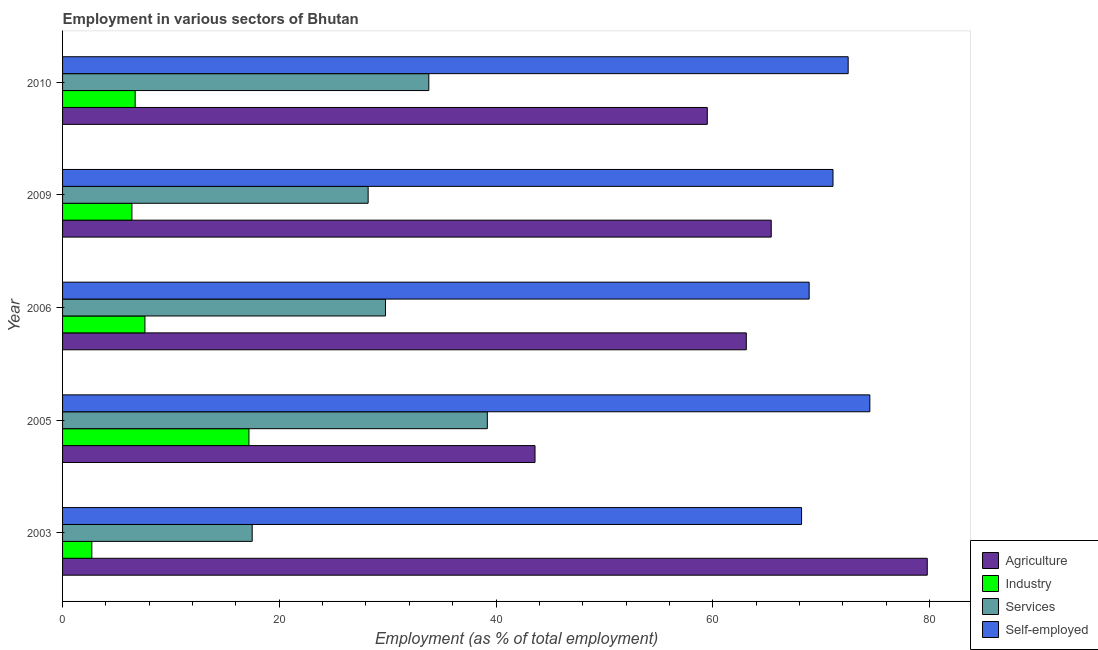Are the number of bars on each tick of the Y-axis equal?
Offer a terse response. Yes. What is the label of the 3rd group of bars from the top?
Offer a terse response. 2006. What is the percentage of workers in industry in 2005?
Your answer should be very brief. 17.2. Across all years, what is the maximum percentage of workers in services?
Your answer should be very brief. 39.2. Across all years, what is the minimum percentage of workers in agriculture?
Offer a terse response. 43.6. In which year was the percentage of self employed workers minimum?
Provide a succinct answer. 2003. What is the total percentage of workers in industry in the graph?
Keep it short and to the point. 40.6. What is the difference between the percentage of workers in industry in 2005 and that in 2010?
Keep it short and to the point. 10.5. What is the difference between the percentage of self employed workers in 2003 and the percentage of workers in industry in 2006?
Provide a short and direct response. 60.6. What is the average percentage of self employed workers per year?
Provide a short and direct response. 71.04. In the year 2010, what is the difference between the percentage of workers in industry and percentage of workers in agriculture?
Your answer should be very brief. -52.8. What is the ratio of the percentage of workers in agriculture in 2006 to that in 2010?
Your response must be concise. 1.06. Is the percentage of self employed workers in 2005 less than that in 2010?
Provide a short and direct response. No. Is the difference between the percentage of self employed workers in 2005 and 2006 greater than the difference between the percentage of workers in services in 2005 and 2006?
Offer a very short reply. No. What is the difference between the highest and the second highest percentage of workers in agriculture?
Your response must be concise. 14.4. What is the difference between the highest and the lowest percentage of workers in agriculture?
Your response must be concise. 36.2. In how many years, is the percentage of workers in industry greater than the average percentage of workers in industry taken over all years?
Give a very brief answer. 1. What does the 3rd bar from the top in 2009 represents?
Your answer should be compact. Industry. What does the 3rd bar from the bottom in 2003 represents?
Offer a terse response. Services. Is it the case that in every year, the sum of the percentage of workers in agriculture and percentage of workers in industry is greater than the percentage of workers in services?
Your answer should be very brief. Yes. Are all the bars in the graph horizontal?
Offer a terse response. Yes. How many years are there in the graph?
Your answer should be compact. 5. Are the values on the major ticks of X-axis written in scientific E-notation?
Provide a short and direct response. No. Does the graph contain any zero values?
Offer a very short reply. No. What is the title of the graph?
Provide a succinct answer. Employment in various sectors of Bhutan. Does "Subsidies and Transfers" appear as one of the legend labels in the graph?
Give a very brief answer. No. What is the label or title of the X-axis?
Your response must be concise. Employment (as % of total employment). What is the Employment (as % of total employment) of Agriculture in 2003?
Your answer should be very brief. 79.8. What is the Employment (as % of total employment) in Industry in 2003?
Offer a very short reply. 2.7. What is the Employment (as % of total employment) in Self-employed in 2003?
Offer a very short reply. 68.2. What is the Employment (as % of total employment) of Agriculture in 2005?
Make the answer very short. 43.6. What is the Employment (as % of total employment) of Industry in 2005?
Provide a succinct answer. 17.2. What is the Employment (as % of total employment) in Services in 2005?
Offer a terse response. 39.2. What is the Employment (as % of total employment) in Self-employed in 2005?
Your response must be concise. 74.5. What is the Employment (as % of total employment) of Agriculture in 2006?
Offer a very short reply. 63.1. What is the Employment (as % of total employment) of Industry in 2006?
Your answer should be compact. 7.6. What is the Employment (as % of total employment) of Services in 2006?
Keep it short and to the point. 29.8. What is the Employment (as % of total employment) of Self-employed in 2006?
Ensure brevity in your answer.  68.9. What is the Employment (as % of total employment) of Agriculture in 2009?
Provide a short and direct response. 65.4. What is the Employment (as % of total employment) of Industry in 2009?
Make the answer very short. 6.4. What is the Employment (as % of total employment) of Services in 2009?
Provide a short and direct response. 28.2. What is the Employment (as % of total employment) in Self-employed in 2009?
Your response must be concise. 71.1. What is the Employment (as % of total employment) in Agriculture in 2010?
Your answer should be compact. 59.5. What is the Employment (as % of total employment) in Industry in 2010?
Give a very brief answer. 6.7. What is the Employment (as % of total employment) of Services in 2010?
Your answer should be very brief. 33.8. What is the Employment (as % of total employment) of Self-employed in 2010?
Ensure brevity in your answer.  72.5. Across all years, what is the maximum Employment (as % of total employment) of Agriculture?
Keep it short and to the point. 79.8. Across all years, what is the maximum Employment (as % of total employment) in Industry?
Offer a terse response. 17.2. Across all years, what is the maximum Employment (as % of total employment) of Services?
Your answer should be compact. 39.2. Across all years, what is the maximum Employment (as % of total employment) in Self-employed?
Your response must be concise. 74.5. Across all years, what is the minimum Employment (as % of total employment) in Agriculture?
Give a very brief answer. 43.6. Across all years, what is the minimum Employment (as % of total employment) in Industry?
Your answer should be compact. 2.7. Across all years, what is the minimum Employment (as % of total employment) in Self-employed?
Offer a very short reply. 68.2. What is the total Employment (as % of total employment) in Agriculture in the graph?
Give a very brief answer. 311.4. What is the total Employment (as % of total employment) in Industry in the graph?
Provide a succinct answer. 40.6. What is the total Employment (as % of total employment) in Services in the graph?
Provide a short and direct response. 148.5. What is the total Employment (as % of total employment) of Self-employed in the graph?
Give a very brief answer. 355.2. What is the difference between the Employment (as % of total employment) of Agriculture in 2003 and that in 2005?
Give a very brief answer. 36.2. What is the difference between the Employment (as % of total employment) in Industry in 2003 and that in 2005?
Keep it short and to the point. -14.5. What is the difference between the Employment (as % of total employment) of Services in 2003 and that in 2005?
Your answer should be very brief. -21.7. What is the difference between the Employment (as % of total employment) in Industry in 2003 and that in 2006?
Keep it short and to the point. -4.9. What is the difference between the Employment (as % of total employment) in Self-employed in 2003 and that in 2006?
Ensure brevity in your answer.  -0.7. What is the difference between the Employment (as % of total employment) in Agriculture in 2003 and that in 2009?
Ensure brevity in your answer.  14.4. What is the difference between the Employment (as % of total employment) in Services in 2003 and that in 2009?
Provide a succinct answer. -10.7. What is the difference between the Employment (as % of total employment) of Agriculture in 2003 and that in 2010?
Your answer should be very brief. 20.3. What is the difference between the Employment (as % of total employment) in Industry in 2003 and that in 2010?
Give a very brief answer. -4. What is the difference between the Employment (as % of total employment) in Services in 2003 and that in 2010?
Your response must be concise. -16.3. What is the difference between the Employment (as % of total employment) of Agriculture in 2005 and that in 2006?
Give a very brief answer. -19.5. What is the difference between the Employment (as % of total employment) in Industry in 2005 and that in 2006?
Your answer should be compact. 9.6. What is the difference between the Employment (as % of total employment) in Agriculture in 2005 and that in 2009?
Your answer should be compact. -21.8. What is the difference between the Employment (as % of total employment) in Services in 2005 and that in 2009?
Ensure brevity in your answer.  11. What is the difference between the Employment (as % of total employment) of Self-employed in 2005 and that in 2009?
Ensure brevity in your answer.  3.4. What is the difference between the Employment (as % of total employment) in Agriculture in 2005 and that in 2010?
Offer a very short reply. -15.9. What is the difference between the Employment (as % of total employment) in Industry in 2005 and that in 2010?
Offer a terse response. 10.5. What is the difference between the Employment (as % of total employment) in Services in 2005 and that in 2010?
Keep it short and to the point. 5.4. What is the difference between the Employment (as % of total employment) in Self-employed in 2005 and that in 2010?
Your answer should be compact. 2. What is the difference between the Employment (as % of total employment) in Agriculture in 2006 and that in 2009?
Your answer should be very brief. -2.3. What is the difference between the Employment (as % of total employment) of Industry in 2006 and that in 2009?
Make the answer very short. 1.2. What is the difference between the Employment (as % of total employment) in Agriculture in 2006 and that in 2010?
Your answer should be compact. 3.6. What is the difference between the Employment (as % of total employment) in Self-employed in 2006 and that in 2010?
Keep it short and to the point. -3.6. What is the difference between the Employment (as % of total employment) in Agriculture in 2009 and that in 2010?
Your answer should be compact. 5.9. What is the difference between the Employment (as % of total employment) of Industry in 2009 and that in 2010?
Provide a succinct answer. -0.3. What is the difference between the Employment (as % of total employment) of Services in 2009 and that in 2010?
Your answer should be very brief. -5.6. What is the difference between the Employment (as % of total employment) of Agriculture in 2003 and the Employment (as % of total employment) of Industry in 2005?
Make the answer very short. 62.6. What is the difference between the Employment (as % of total employment) of Agriculture in 2003 and the Employment (as % of total employment) of Services in 2005?
Offer a very short reply. 40.6. What is the difference between the Employment (as % of total employment) in Industry in 2003 and the Employment (as % of total employment) in Services in 2005?
Make the answer very short. -36.5. What is the difference between the Employment (as % of total employment) in Industry in 2003 and the Employment (as % of total employment) in Self-employed in 2005?
Give a very brief answer. -71.8. What is the difference between the Employment (as % of total employment) of Services in 2003 and the Employment (as % of total employment) of Self-employed in 2005?
Provide a short and direct response. -57. What is the difference between the Employment (as % of total employment) in Agriculture in 2003 and the Employment (as % of total employment) in Industry in 2006?
Provide a short and direct response. 72.2. What is the difference between the Employment (as % of total employment) of Agriculture in 2003 and the Employment (as % of total employment) of Self-employed in 2006?
Your answer should be very brief. 10.9. What is the difference between the Employment (as % of total employment) in Industry in 2003 and the Employment (as % of total employment) in Services in 2006?
Make the answer very short. -27.1. What is the difference between the Employment (as % of total employment) of Industry in 2003 and the Employment (as % of total employment) of Self-employed in 2006?
Make the answer very short. -66.2. What is the difference between the Employment (as % of total employment) in Services in 2003 and the Employment (as % of total employment) in Self-employed in 2006?
Your answer should be very brief. -51.4. What is the difference between the Employment (as % of total employment) of Agriculture in 2003 and the Employment (as % of total employment) of Industry in 2009?
Make the answer very short. 73.4. What is the difference between the Employment (as % of total employment) of Agriculture in 2003 and the Employment (as % of total employment) of Services in 2009?
Make the answer very short. 51.6. What is the difference between the Employment (as % of total employment) in Agriculture in 2003 and the Employment (as % of total employment) in Self-employed in 2009?
Your answer should be compact. 8.7. What is the difference between the Employment (as % of total employment) of Industry in 2003 and the Employment (as % of total employment) of Services in 2009?
Provide a short and direct response. -25.5. What is the difference between the Employment (as % of total employment) in Industry in 2003 and the Employment (as % of total employment) in Self-employed in 2009?
Give a very brief answer. -68.4. What is the difference between the Employment (as % of total employment) in Services in 2003 and the Employment (as % of total employment) in Self-employed in 2009?
Your response must be concise. -53.6. What is the difference between the Employment (as % of total employment) of Agriculture in 2003 and the Employment (as % of total employment) of Industry in 2010?
Offer a very short reply. 73.1. What is the difference between the Employment (as % of total employment) of Industry in 2003 and the Employment (as % of total employment) of Services in 2010?
Ensure brevity in your answer.  -31.1. What is the difference between the Employment (as % of total employment) in Industry in 2003 and the Employment (as % of total employment) in Self-employed in 2010?
Your response must be concise. -69.8. What is the difference between the Employment (as % of total employment) of Services in 2003 and the Employment (as % of total employment) of Self-employed in 2010?
Make the answer very short. -55. What is the difference between the Employment (as % of total employment) in Agriculture in 2005 and the Employment (as % of total employment) in Industry in 2006?
Your answer should be compact. 36. What is the difference between the Employment (as % of total employment) of Agriculture in 2005 and the Employment (as % of total employment) of Services in 2006?
Offer a terse response. 13.8. What is the difference between the Employment (as % of total employment) in Agriculture in 2005 and the Employment (as % of total employment) in Self-employed in 2006?
Offer a very short reply. -25.3. What is the difference between the Employment (as % of total employment) of Industry in 2005 and the Employment (as % of total employment) of Self-employed in 2006?
Provide a short and direct response. -51.7. What is the difference between the Employment (as % of total employment) of Services in 2005 and the Employment (as % of total employment) of Self-employed in 2006?
Offer a terse response. -29.7. What is the difference between the Employment (as % of total employment) in Agriculture in 2005 and the Employment (as % of total employment) in Industry in 2009?
Provide a succinct answer. 37.2. What is the difference between the Employment (as % of total employment) of Agriculture in 2005 and the Employment (as % of total employment) of Self-employed in 2009?
Your answer should be compact. -27.5. What is the difference between the Employment (as % of total employment) of Industry in 2005 and the Employment (as % of total employment) of Services in 2009?
Offer a terse response. -11. What is the difference between the Employment (as % of total employment) in Industry in 2005 and the Employment (as % of total employment) in Self-employed in 2009?
Provide a short and direct response. -53.9. What is the difference between the Employment (as % of total employment) in Services in 2005 and the Employment (as % of total employment) in Self-employed in 2009?
Your answer should be very brief. -31.9. What is the difference between the Employment (as % of total employment) of Agriculture in 2005 and the Employment (as % of total employment) of Industry in 2010?
Provide a short and direct response. 36.9. What is the difference between the Employment (as % of total employment) of Agriculture in 2005 and the Employment (as % of total employment) of Self-employed in 2010?
Make the answer very short. -28.9. What is the difference between the Employment (as % of total employment) of Industry in 2005 and the Employment (as % of total employment) of Services in 2010?
Offer a terse response. -16.6. What is the difference between the Employment (as % of total employment) in Industry in 2005 and the Employment (as % of total employment) in Self-employed in 2010?
Your response must be concise. -55.3. What is the difference between the Employment (as % of total employment) in Services in 2005 and the Employment (as % of total employment) in Self-employed in 2010?
Offer a terse response. -33.3. What is the difference between the Employment (as % of total employment) of Agriculture in 2006 and the Employment (as % of total employment) of Industry in 2009?
Keep it short and to the point. 56.7. What is the difference between the Employment (as % of total employment) of Agriculture in 2006 and the Employment (as % of total employment) of Services in 2009?
Offer a very short reply. 34.9. What is the difference between the Employment (as % of total employment) of Industry in 2006 and the Employment (as % of total employment) of Services in 2009?
Make the answer very short. -20.6. What is the difference between the Employment (as % of total employment) of Industry in 2006 and the Employment (as % of total employment) of Self-employed in 2009?
Give a very brief answer. -63.5. What is the difference between the Employment (as % of total employment) in Services in 2006 and the Employment (as % of total employment) in Self-employed in 2009?
Your response must be concise. -41.3. What is the difference between the Employment (as % of total employment) in Agriculture in 2006 and the Employment (as % of total employment) in Industry in 2010?
Keep it short and to the point. 56.4. What is the difference between the Employment (as % of total employment) in Agriculture in 2006 and the Employment (as % of total employment) in Services in 2010?
Offer a terse response. 29.3. What is the difference between the Employment (as % of total employment) in Agriculture in 2006 and the Employment (as % of total employment) in Self-employed in 2010?
Ensure brevity in your answer.  -9.4. What is the difference between the Employment (as % of total employment) in Industry in 2006 and the Employment (as % of total employment) in Services in 2010?
Ensure brevity in your answer.  -26.2. What is the difference between the Employment (as % of total employment) in Industry in 2006 and the Employment (as % of total employment) in Self-employed in 2010?
Your answer should be compact. -64.9. What is the difference between the Employment (as % of total employment) of Services in 2006 and the Employment (as % of total employment) of Self-employed in 2010?
Offer a terse response. -42.7. What is the difference between the Employment (as % of total employment) in Agriculture in 2009 and the Employment (as % of total employment) in Industry in 2010?
Ensure brevity in your answer.  58.7. What is the difference between the Employment (as % of total employment) in Agriculture in 2009 and the Employment (as % of total employment) in Services in 2010?
Ensure brevity in your answer.  31.6. What is the difference between the Employment (as % of total employment) in Industry in 2009 and the Employment (as % of total employment) in Services in 2010?
Ensure brevity in your answer.  -27.4. What is the difference between the Employment (as % of total employment) of Industry in 2009 and the Employment (as % of total employment) of Self-employed in 2010?
Offer a very short reply. -66.1. What is the difference between the Employment (as % of total employment) of Services in 2009 and the Employment (as % of total employment) of Self-employed in 2010?
Offer a terse response. -44.3. What is the average Employment (as % of total employment) in Agriculture per year?
Provide a succinct answer. 62.28. What is the average Employment (as % of total employment) of Industry per year?
Your answer should be very brief. 8.12. What is the average Employment (as % of total employment) of Services per year?
Provide a succinct answer. 29.7. What is the average Employment (as % of total employment) of Self-employed per year?
Provide a succinct answer. 71.04. In the year 2003, what is the difference between the Employment (as % of total employment) of Agriculture and Employment (as % of total employment) of Industry?
Offer a terse response. 77.1. In the year 2003, what is the difference between the Employment (as % of total employment) of Agriculture and Employment (as % of total employment) of Services?
Your response must be concise. 62.3. In the year 2003, what is the difference between the Employment (as % of total employment) of Agriculture and Employment (as % of total employment) of Self-employed?
Ensure brevity in your answer.  11.6. In the year 2003, what is the difference between the Employment (as % of total employment) in Industry and Employment (as % of total employment) in Services?
Your answer should be very brief. -14.8. In the year 2003, what is the difference between the Employment (as % of total employment) of Industry and Employment (as % of total employment) of Self-employed?
Your answer should be compact. -65.5. In the year 2003, what is the difference between the Employment (as % of total employment) of Services and Employment (as % of total employment) of Self-employed?
Offer a terse response. -50.7. In the year 2005, what is the difference between the Employment (as % of total employment) of Agriculture and Employment (as % of total employment) of Industry?
Provide a short and direct response. 26.4. In the year 2005, what is the difference between the Employment (as % of total employment) in Agriculture and Employment (as % of total employment) in Services?
Offer a very short reply. 4.4. In the year 2005, what is the difference between the Employment (as % of total employment) in Agriculture and Employment (as % of total employment) in Self-employed?
Your response must be concise. -30.9. In the year 2005, what is the difference between the Employment (as % of total employment) in Industry and Employment (as % of total employment) in Self-employed?
Keep it short and to the point. -57.3. In the year 2005, what is the difference between the Employment (as % of total employment) in Services and Employment (as % of total employment) in Self-employed?
Make the answer very short. -35.3. In the year 2006, what is the difference between the Employment (as % of total employment) of Agriculture and Employment (as % of total employment) of Industry?
Provide a succinct answer. 55.5. In the year 2006, what is the difference between the Employment (as % of total employment) in Agriculture and Employment (as % of total employment) in Services?
Give a very brief answer. 33.3. In the year 2006, what is the difference between the Employment (as % of total employment) in Agriculture and Employment (as % of total employment) in Self-employed?
Ensure brevity in your answer.  -5.8. In the year 2006, what is the difference between the Employment (as % of total employment) of Industry and Employment (as % of total employment) of Services?
Keep it short and to the point. -22.2. In the year 2006, what is the difference between the Employment (as % of total employment) in Industry and Employment (as % of total employment) in Self-employed?
Keep it short and to the point. -61.3. In the year 2006, what is the difference between the Employment (as % of total employment) in Services and Employment (as % of total employment) in Self-employed?
Your answer should be compact. -39.1. In the year 2009, what is the difference between the Employment (as % of total employment) in Agriculture and Employment (as % of total employment) in Industry?
Provide a short and direct response. 59. In the year 2009, what is the difference between the Employment (as % of total employment) of Agriculture and Employment (as % of total employment) of Services?
Keep it short and to the point. 37.2. In the year 2009, what is the difference between the Employment (as % of total employment) of Agriculture and Employment (as % of total employment) of Self-employed?
Your response must be concise. -5.7. In the year 2009, what is the difference between the Employment (as % of total employment) of Industry and Employment (as % of total employment) of Services?
Make the answer very short. -21.8. In the year 2009, what is the difference between the Employment (as % of total employment) in Industry and Employment (as % of total employment) in Self-employed?
Your answer should be compact. -64.7. In the year 2009, what is the difference between the Employment (as % of total employment) in Services and Employment (as % of total employment) in Self-employed?
Keep it short and to the point. -42.9. In the year 2010, what is the difference between the Employment (as % of total employment) in Agriculture and Employment (as % of total employment) in Industry?
Your answer should be very brief. 52.8. In the year 2010, what is the difference between the Employment (as % of total employment) in Agriculture and Employment (as % of total employment) in Services?
Your response must be concise. 25.7. In the year 2010, what is the difference between the Employment (as % of total employment) in Industry and Employment (as % of total employment) in Services?
Keep it short and to the point. -27.1. In the year 2010, what is the difference between the Employment (as % of total employment) in Industry and Employment (as % of total employment) in Self-employed?
Make the answer very short. -65.8. In the year 2010, what is the difference between the Employment (as % of total employment) in Services and Employment (as % of total employment) in Self-employed?
Ensure brevity in your answer.  -38.7. What is the ratio of the Employment (as % of total employment) of Agriculture in 2003 to that in 2005?
Your answer should be compact. 1.83. What is the ratio of the Employment (as % of total employment) of Industry in 2003 to that in 2005?
Offer a terse response. 0.16. What is the ratio of the Employment (as % of total employment) in Services in 2003 to that in 2005?
Offer a very short reply. 0.45. What is the ratio of the Employment (as % of total employment) of Self-employed in 2003 to that in 2005?
Give a very brief answer. 0.92. What is the ratio of the Employment (as % of total employment) of Agriculture in 2003 to that in 2006?
Offer a terse response. 1.26. What is the ratio of the Employment (as % of total employment) in Industry in 2003 to that in 2006?
Offer a very short reply. 0.36. What is the ratio of the Employment (as % of total employment) of Services in 2003 to that in 2006?
Offer a terse response. 0.59. What is the ratio of the Employment (as % of total employment) in Agriculture in 2003 to that in 2009?
Make the answer very short. 1.22. What is the ratio of the Employment (as % of total employment) in Industry in 2003 to that in 2009?
Offer a very short reply. 0.42. What is the ratio of the Employment (as % of total employment) of Services in 2003 to that in 2009?
Your answer should be compact. 0.62. What is the ratio of the Employment (as % of total employment) of Self-employed in 2003 to that in 2009?
Offer a terse response. 0.96. What is the ratio of the Employment (as % of total employment) of Agriculture in 2003 to that in 2010?
Give a very brief answer. 1.34. What is the ratio of the Employment (as % of total employment) of Industry in 2003 to that in 2010?
Your answer should be compact. 0.4. What is the ratio of the Employment (as % of total employment) of Services in 2003 to that in 2010?
Provide a short and direct response. 0.52. What is the ratio of the Employment (as % of total employment) in Self-employed in 2003 to that in 2010?
Your answer should be very brief. 0.94. What is the ratio of the Employment (as % of total employment) of Agriculture in 2005 to that in 2006?
Your response must be concise. 0.69. What is the ratio of the Employment (as % of total employment) of Industry in 2005 to that in 2006?
Your response must be concise. 2.26. What is the ratio of the Employment (as % of total employment) of Services in 2005 to that in 2006?
Offer a terse response. 1.32. What is the ratio of the Employment (as % of total employment) in Self-employed in 2005 to that in 2006?
Ensure brevity in your answer.  1.08. What is the ratio of the Employment (as % of total employment) of Industry in 2005 to that in 2009?
Offer a terse response. 2.69. What is the ratio of the Employment (as % of total employment) of Services in 2005 to that in 2009?
Keep it short and to the point. 1.39. What is the ratio of the Employment (as % of total employment) in Self-employed in 2005 to that in 2009?
Your answer should be compact. 1.05. What is the ratio of the Employment (as % of total employment) in Agriculture in 2005 to that in 2010?
Offer a terse response. 0.73. What is the ratio of the Employment (as % of total employment) of Industry in 2005 to that in 2010?
Provide a succinct answer. 2.57. What is the ratio of the Employment (as % of total employment) in Services in 2005 to that in 2010?
Make the answer very short. 1.16. What is the ratio of the Employment (as % of total employment) of Self-employed in 2005 to that in 2010?
Your answer should be compact. 1.03. What is the ratio of the Employment (as % of total employment) of Agriculture in 2006 to that in 2009?
Make the answer very short. 0.96. What is the ratio of the Employment (as % of total employment) in Industry in 2006 to that in 2009?
Make the answer very short. 1.19. What is the ratio of the Employment (as % of total employment) of Services in 2006 to that in 2009?
Provide a succinct answer. 1.06. What is the ratio of the Employment (as % of total employment) of Self-employed in 2006 to that in 2009?
Give a very brief answer. 0.97. What is the ratio of the Employment (as % of total employment) in Agriculture in 2006 to that in 2010?
Offer a very short reply. 1.06. What is the ratio of the Employment (as % of total employment) of Industry in 2006 to that in 2010?
Make the answer very short. 1.13. What is the ratio of the Employment (as % of total employment) in Services in 2006 to that in 2010?
Your response must be concise. 0.88. What is the ratio of the Employment (as % of total employment) of Self-employed in 2006 to that in 2010?
Provide a succinct answer. 0.95. What is the ratio of the Employment (as % of total employment) in Agriculture in 2009 to that in 2010?
Your answer should be compact. 1.1. What is the ratio of the Employment (as % of total employment) in Industry in 2009 to that in 2010?
Provide a succinct answer. 0.96. What is the ratio of the Employment (as % of total employment) in Services in 2009 to that in 2010?
Keep it short and to the point. 0.83. What is the ratio of the Employment (as % of total employment) of Self-employed in 2009 to that in 2010?
Provide a succinct answer. 0.98. What is the difference between the highest and the second highest Employment (as % of total employment) in Self-employed?
Your response must be concise. 2. What is the difference between the highest and the lowest Employment (as % of total employment) in Agriculture?
Provide a short and direct response. 36.2. What is the difference between the highest and the lowest Employment (as % of total employment) of Industry?
Your response must be concise. 14.5. What is the difference between the highest and the lowest Employment (as % of total employment) of Services?
Provide a succinct answer. 21.7. 